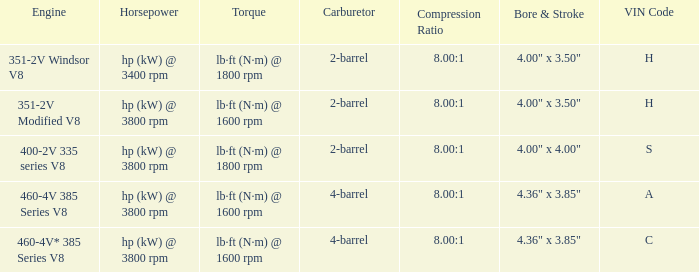What are the dimensions for bore and stroke in an engine featuring a 4-barrel carburetor and an a vin code? 4.36" x 3.85". 